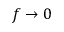<formula> <loc_0><loc_0><loc_500><loc_500>f \rightarrow 0</formula> 